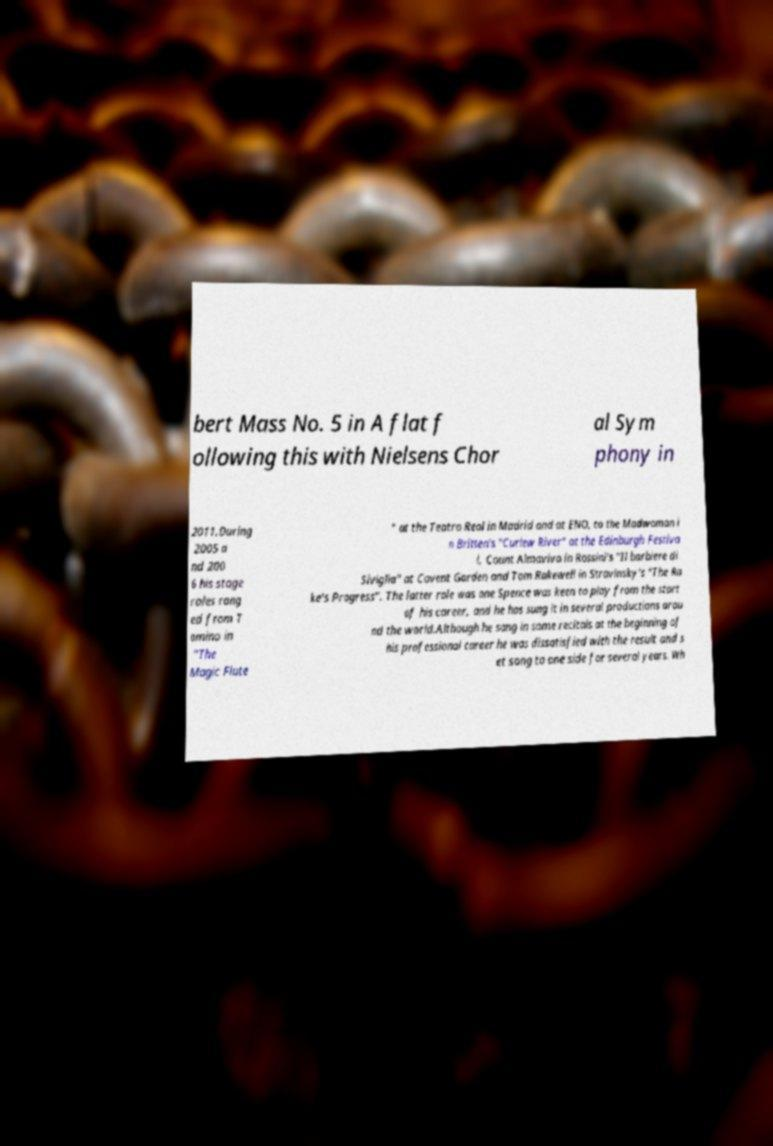Could you extract and type out the text from this image? bert Mass No. 5 in A flat f ollowing this with Nielsens Chor al Sym phony in 2011.During 2005 a nd 200 6 his stage roles rang ed from T amino in "The Magic Flute " at the Teatro Real in Madrid and at ENO, to the Madwoman i n Britten's "Curlew River" at the Edinburgh Festiva l, Count Almaviva in Rossini's "Il barbiere di Siviglia" at Covent Garden and Tom Rakewell in Stravinsky's "The Ra ke's Progress". The latter role was one Spence was keen to play from the start of his career, and he has sung it in several productions arou nd the world.Although he sang in some recitals at the beginning of his professional career he was dissatisfied with the result and s et song to one side for several years. Wh 